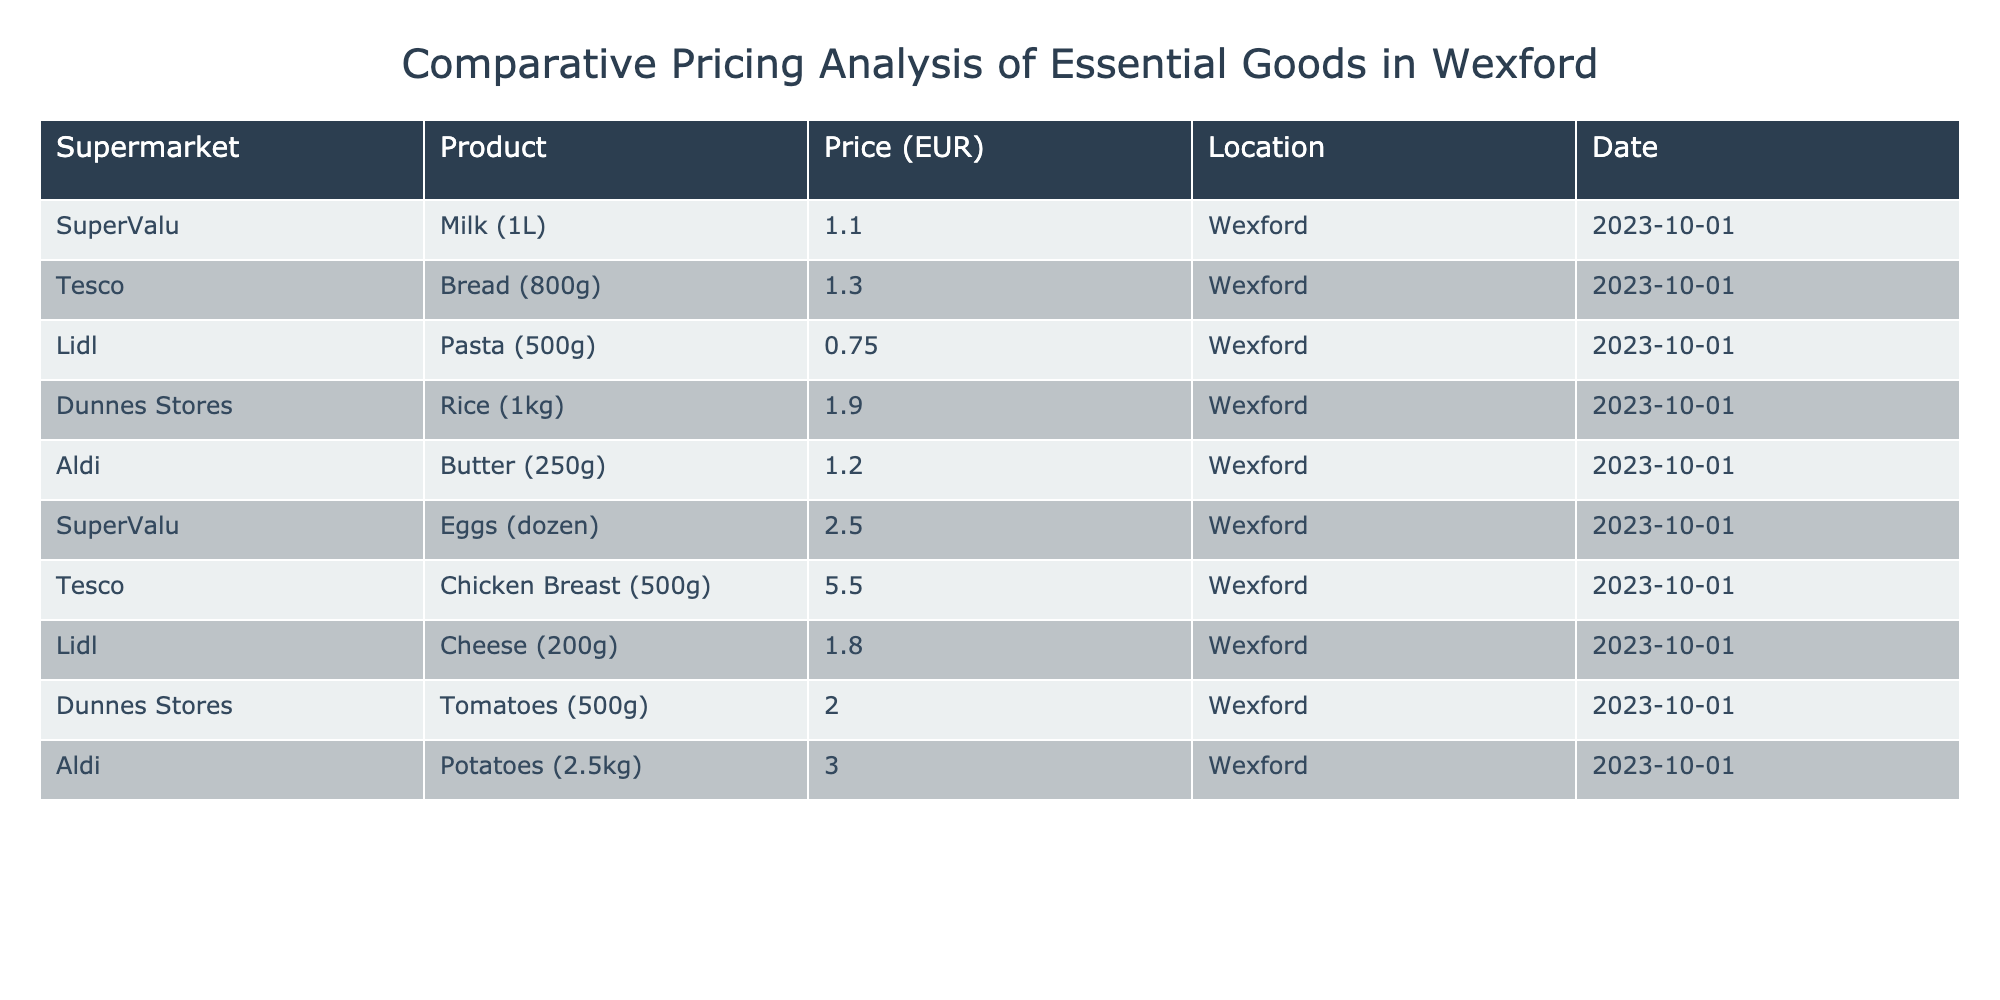What is the price of milk at SuperValu? The table explicitly lists the price of milk (1L) at SuperValu, which is 1.10 EUR.
Answer: 1.10 EUR Which supermarket has the cheapest pasta? According to the table, Lidl offers pasta (500g) at 0.75 EUR, which is lower than the prices of pasta at the other listed supermarkets.
Answer: Lidl What is the total price of a dozen eggs and a 250g butter? The price of a dozen eggs at SuperValu is 2.50 EUR, and the price of butter (250g) at Aldi is 1.20 EUR. Adding these prices together gives 2.50 + 1.20 = 3.70 EUR.
Answer: 3.70 EUR Does Tesco offer chicken breast for less than 6 EUR? The table shows that Tesco sells chicken breast (500g) for 5.50 EUR, which is indeed less than 6 EUR.
Answer: Yes What is the difference in price between the cheapest and most expensive item listed? The cheapest item listed in the table is pasta at 0.75 EUR (Lidl), and the most expensive item is chicken breast at 5.50 EUR (Tesco). The difference is 5.50 - 0.75 = 4.75 EUR.
Answer: 4.75 EUR What is the average cost of the dairy products listed? The dairy products in the table are milk (1.10 EUR), butter (1.20 EUR), and cheese (1.80 EUR). To find the average, sum these prices: 1.10 + 1.20 + 1.80 = 4.10 EUR. Then divide by the number of items (3): 4.10 / 3 = 1.37 EUR (approximately).
Answer: 1.37 EUR Is there any supermarket in Wexford that sells tomatoes for less than 2 EUR? The table indicates that the price of tomatoes (500g) at Dunnes Stores is 2.00 EUR, which is not less than 2 EUR. Therefore, there is no supermarket offering tomatoes at under 2 EUR.
Answer: No What is the highest price for any product in Aldi? From the table, the only product listed from Aldi is butter (250g) at 1.20 EUR. Therefore, the highest price for any product in Aldi is 1.20 EUR.
Answer: 1.20 EUR Which supermarket provides the most products in this table? Looking through the table, SuperValu has the most items listed with two products (milk and eggs), while other supermarkets have one product each. This makes SuperValu the supermarket with the most products.
Answer: SuperValu 